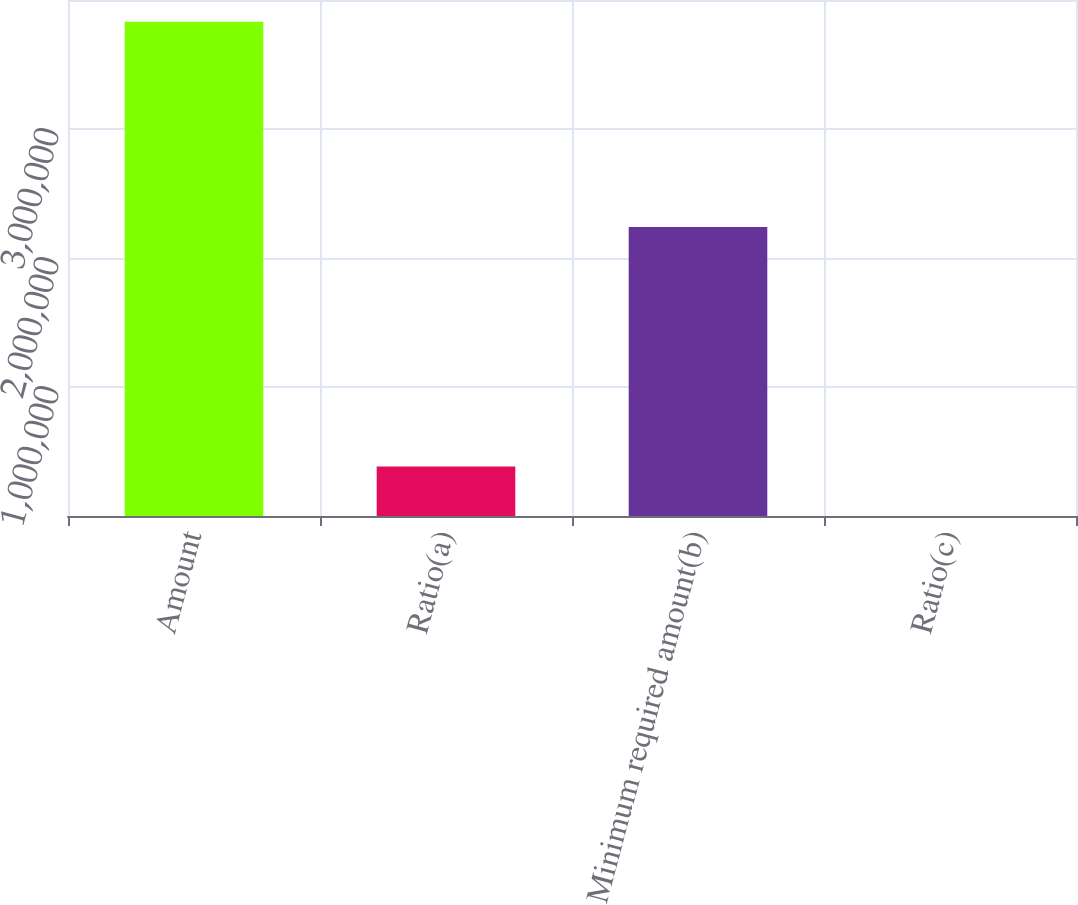<chart> <loc_0><loc_0><loc_500><loc_500><bar_chart><fcel>Amount<fcel>Ratio(a)<fcel>Minimum required amount(b)<fcel>Ratio(c)<nl><fcel>3.8314e+06<fcel>383146<fcel>2.24051e+06<fcel>6.59<nl></chart> 